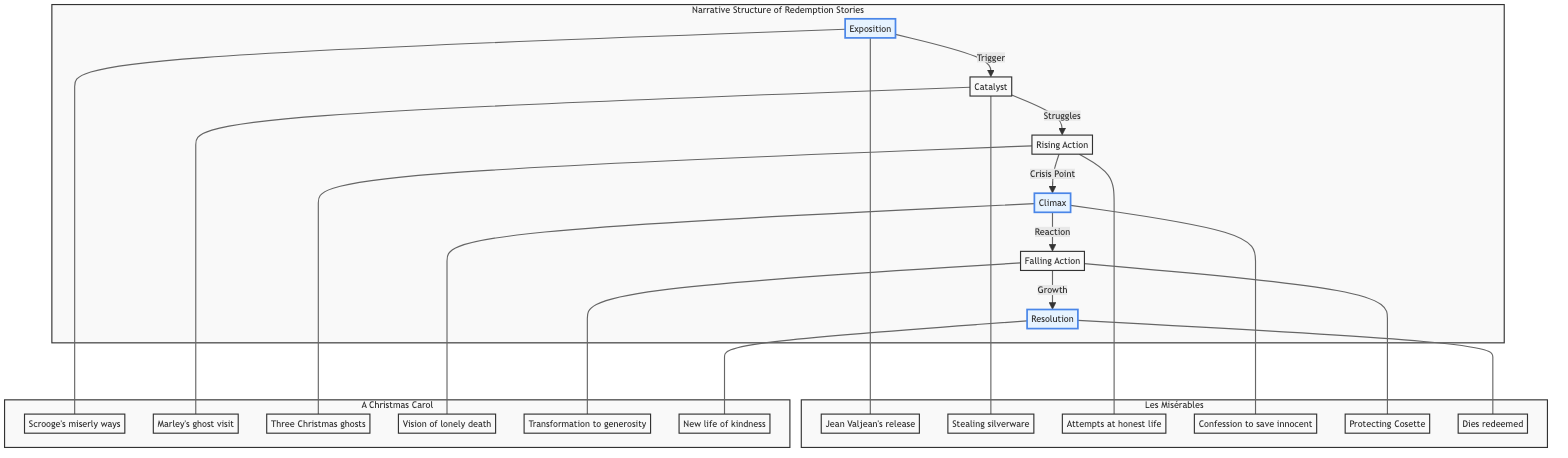What is the first step in the narrative structure of redemption stories? The diagram indicates that the first step is the "Exposition," which sets the stage for the narrative.
Answer: Exposition How many main components are presented in the redemption story structure? The diagram shows six main components: Exposition, Catalyst, Rising Action, Climax, Falling Action, and Resolution.
Answer: Six What key moment comes after the "Crisis Point"? Following the "Crisis Point," the next key moment is the "Climax," which is indicated directly in the flow of the diagram.
Answer: Climax In "A Christmas Carol," what is the action associated with the "Falling Action"? The "Falling Action" in "A Christmas Carol" is represented by the transformation to generosity, which comes after the climax of facing a vision of lonely death.
Answer: Transformation to generosity Which character's redemption ends with "Dies redeemed"? The character associated with "Dies redeemed," as presented in the diagram, is Jean Valjean from "Les Misérables."
Answer: Jean Valjean What element connects the "Exposition" to Jean Valjean's release? The connection is direct as it indicates that the "Exposition" starts with Jean Valjean's release, part of the narrative arc depicted in the diagram.
Answer: Jean Valjean's release What is the relationship between "Marley's ghost visit" and the "Catalyst"? "Marley's ghost visit" serves as the "Catalyst" for the narrative in "A Christmas Carol," as indicated in the diagram linking the two elements.
Answer: Catalyst Which narrative structure point does "Protecting Cosette" fulfill? "Protecting Cosette" is identified as a part of the "Falling Action" within the narrative structure for "Les Misérables," demonstrating the character's growth.
Answer: Falling Action What do the highlighted elements in the diagram signify? The highlighted elements in the diagram represent critical points in the narrative structure: Exposition, Climax, and Resolution, indicating their importance in redemptive narratives.
Answer: Critical points 